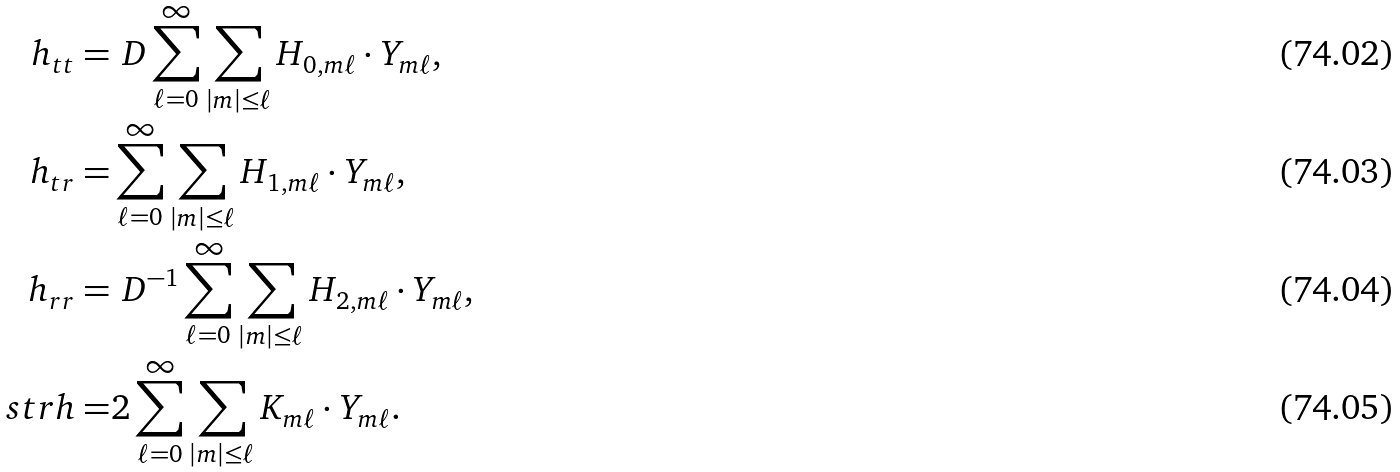<formula> <loc_0><loc_0><loc_500><loc_500>h _ { t t } = & \ D \sum _ { \ell = 0 } ^ { \infty } \sum _ { | m | \leq \ell } H _ { 0 , m \ell } \cdot Y _ { m \ell } , \\ h _ { t r } = & \sum _ { \ell = 0 } ^ { \infty } \sum _ { | m | \leq \ell } H _ { 1 , m \ell } \cdot Y _ { m \ell } , \\ h _ { r r } = & \ D ^ { - 1 } \sum _ { \ell = 0 } ^ { \infty } \sum _ { | m | \leq \ell } H _ { 2 , m \ell } \cdot Y _ { m \ell } , \\ \ s { t r } h = & 2 \sum _ { \ell = 0 } ^ { \infty } \sum _ { | m | \leq \ell } K _ { m \ell } \cdot Y _ { m \ell } .</formula> 